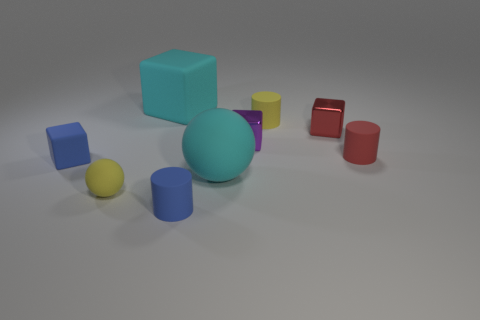Is the material of the large object in front of the cyan rubber cube the same as the small purple block?
Your response must be concise. No. Are there fewer small blue things that are to the right of the purple block than tiny blue cubes?
Provide a short and direct response. Yes. What number of rubber objects are either blue things or tiny objects?
Your response must be concise. 5. Is the color of the big rubber sphere the same as the big rubber cube?
Your response must be concise. Yes. Is there any other thing that has the same color as the tiny matte sphere?
Ensure brevity in your answer.  Yes. There is a large cyan thing behind the red rubber thing; does it have the same shape as the metal thing that is to the right of the yellow cylinder?
Offer a very short reply. Yes. What number of objects are either matte spheres or objects that are behind the blue cylinder?
Offer a very short reply. 8. How many other objects are the same size as the red metal thing?
Ensure brevity in your answer.  6. Do the tiny yellow thing behind the small red shiny object and the small blue object that is on the right side of the cyan block have the same material?
Give a very brief answer. Yes. There is a red metal thing; what number of red objects are in front of it?
Offer a terse response. 1. 